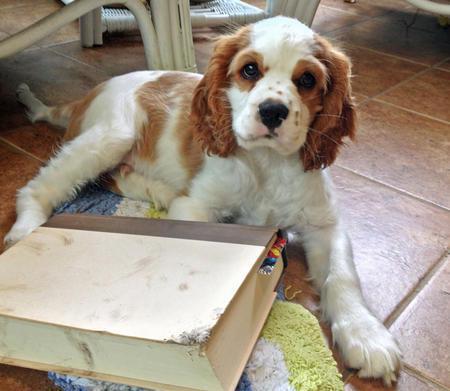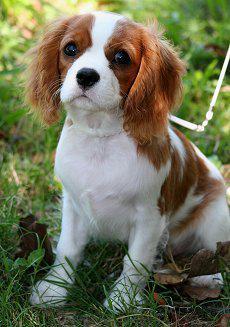The first image is the image on the left, the second image is the image on the right. For the images shown, is this caption "Each image contains exactly one spaniel, and only the dog on the right is posed on real grass." true? Answer yes or no. Yes. 